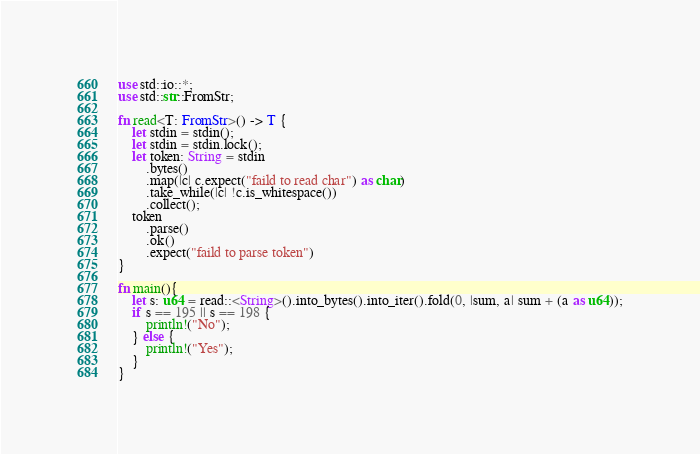Convert code to text. <code><loc_0><loc_0><loc_500><loc_500><_Rust_>use std::io::*;
use std::str::FromStr;

fn read<T: FromStr>() -> T {
    let stdin = stdin();
    let stdin = stdin.lock();
    let token: String = stdin
        .bytes()
        .map(|c| c.expect("faild to read char") as char)
        .take_while(|c| !c.is_whitespace())
        .collect();
    token
        .parse()
        .ok()
        .expect("faild to parse token")
}

fn main(){
    let s: u64 = read::<String>().into_bytes().into_iter().fold(0, |sum, a| sum + (a as u64));
    if s == 195 || s == 198 {
        println!("No");
    } else {
        println!("Yes");
    }
}

</code> 